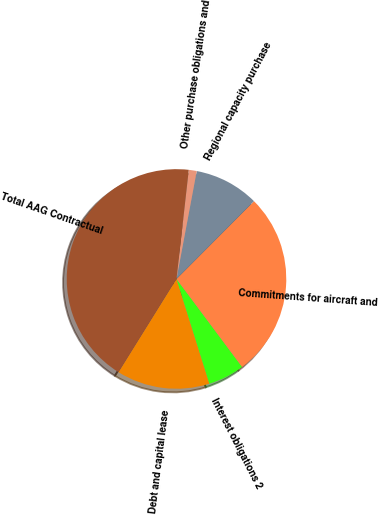Convert chart to OTSL. <chart><loc_0><loc_0><loc_500><loc_500><pie_chart><fcel>Debt and capital lease<fcel>Interest obligations 2<fcel>Commitments for aircraft and<fcel>Regional capacity purchase<fcel>Other purchase obligations and<fcel>Total AAG Contractual<nl><fcel>13.7%<fcel>5.35%<fcel>27.33%<fcel>9.52%<fcel>1.17%<fcel>42.93%<nl></chart> 